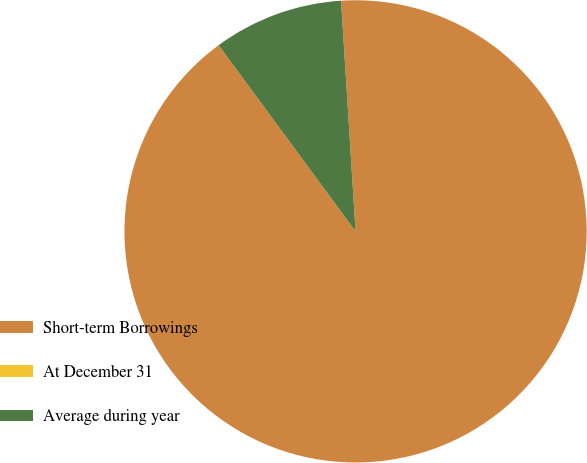<chart> <loc_0><loc_0><loc_500><loc_500><pie_chart><fcel>Short-term Borrowings<fcel>At December 31<fcel>Average during year<nl><fcel>90.9%<fcel>0.0%<fcel>9.09%<nl></chart> 